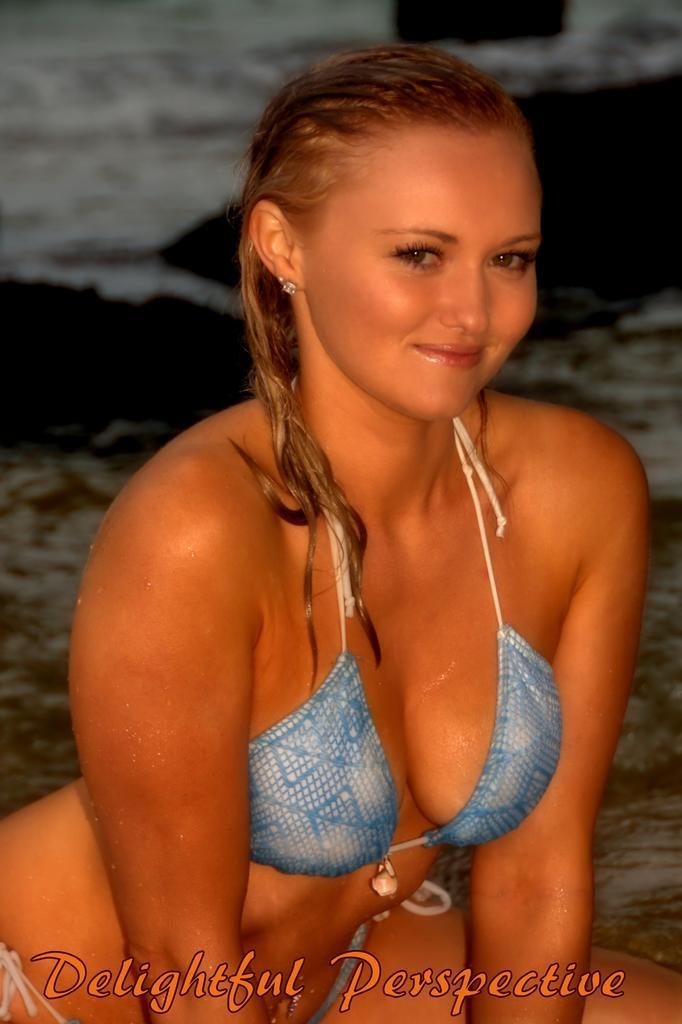Can you describe this image briefly? In this picture we can see a woman, she is smiling and in the background we can see water, at the bottom we can see some text on it. 